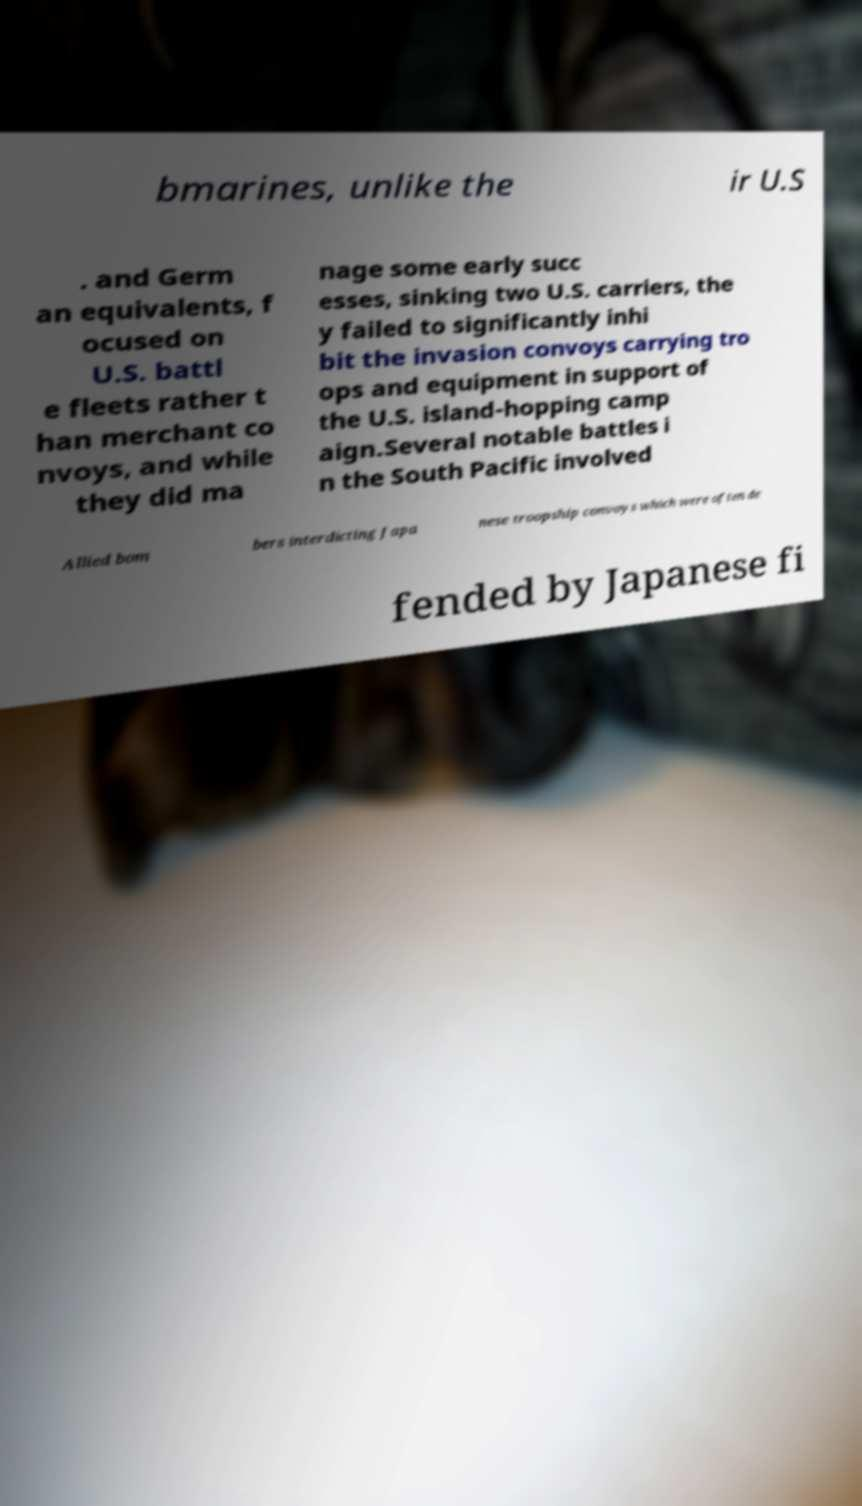Please identify and transcribe the text found in this image. bmarines, unlike the ir U.S . and Germ an equivalents, f ocused on U.S. battl e fleets rather t han merchant co nvoys, and while they did ma nage some early succ esses, sinking two U.S. carriers, the y failed to significantly inhi bit the invasion convoys carrying tro ops and equipment in support of the U.S. island-hopping camp aign.Several notable battles i n the South Pacific involved Allied bom bers interdicting Japa nese troopship convoys which were often de fended by Japanese fi 